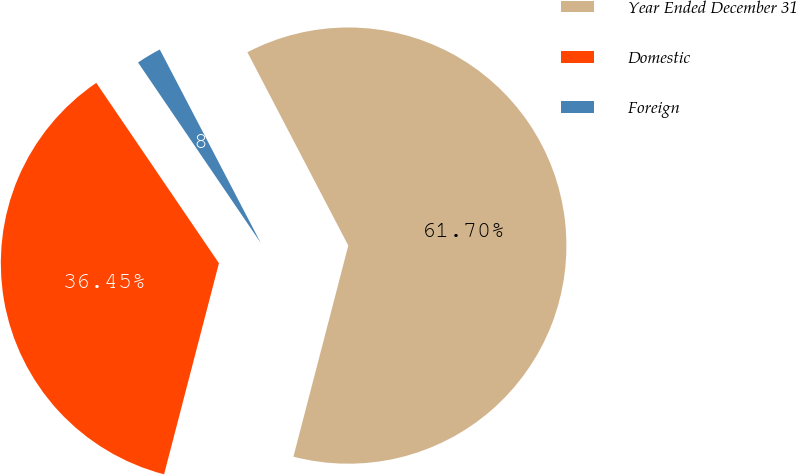Convert chart to OTSL. <chart><loc_0><loc_0><loc_500><loc_500><pie_chart><fcel>Year Ended December 31<fcel>Domestic<fcel>Foreign<nl><fcel>61.71%<fcel>36.45%<fcel>1.85%<nl></chart> 